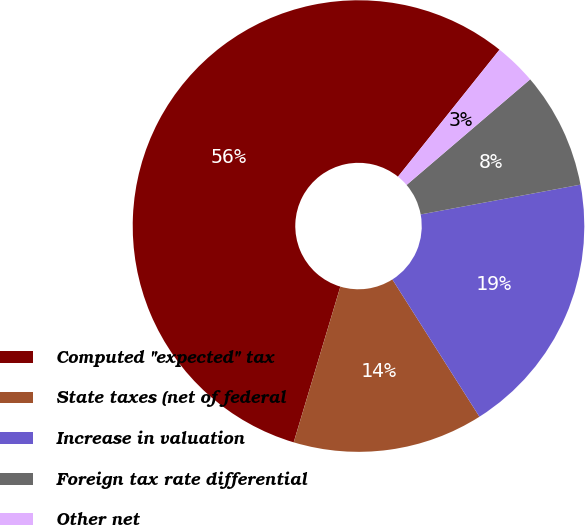Convert chart to OTSL. <chart><loc_0><loc_0><loc_500><loc_500><pie_chart><fcel>Computed ''expected'' tax<fcel>State taxes (net of federal<fcel>Increase in valuation<fcel>Foreign tax rate differential<fcel>Other net<nl><fcel>56.1%<fcel>13.63%<fcel>18.94%<fcel>8.32%<fcel>3.01%<nl></chart> 